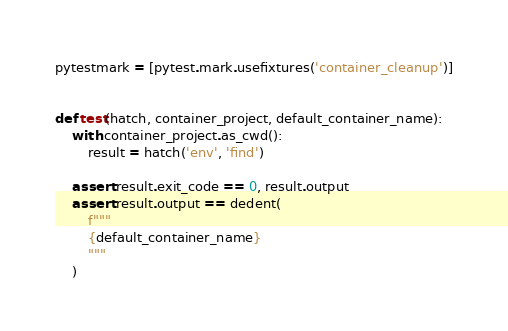<code> <loc_0><loc_0><loc_500><loc_500><_Python_>
pytestmark = [pytest.mark.usefixtures('container_cleanup')]


def test(hatch, container_project, default_container_name):
    with container_project.as_cwd():
        result = hatch('env', 'find')

    assert result.exit_code == 0, result.output
    assert result.output == dedent(
        f"""
        {default_container_name}
        """
    )
</code> 